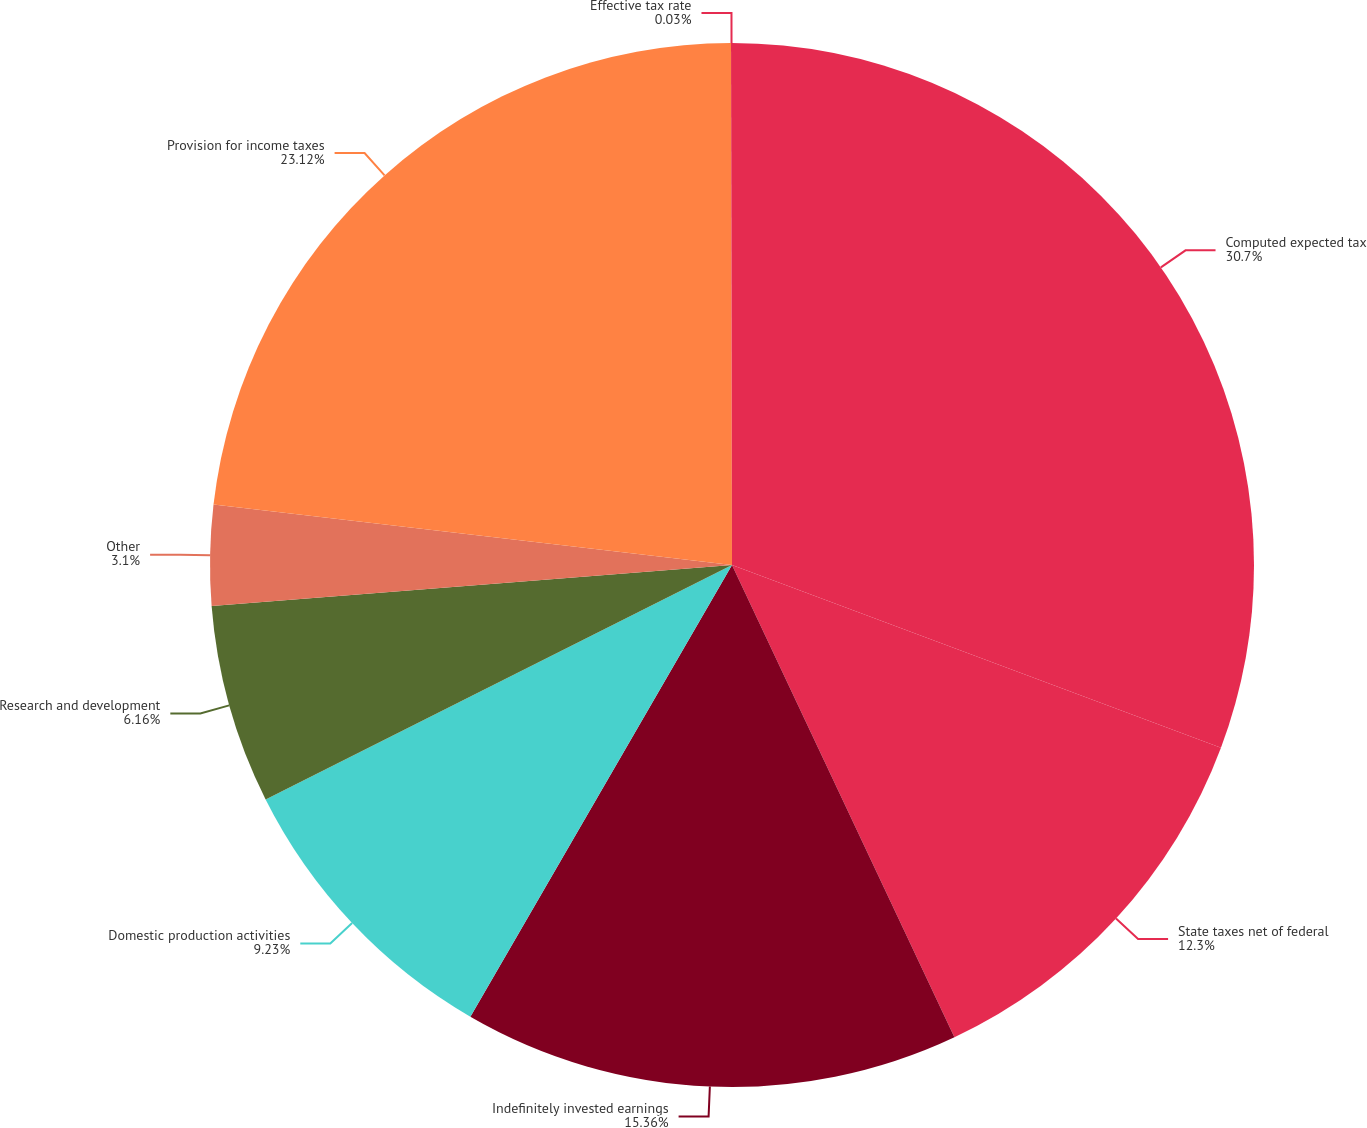<chart> <loc_0><loc_0><loc_500><loc_500><pie_chart><fcel>Computed expected tax<fcel>State taxes net of federal<fcel>Indefinitely invested earnings<fcel>Domestic production activities<fcel>Research and development<fcel>Other<fcel>Provision for income taxes<fcel>Effective tax rate<nl><fcel>30.69%<fcel>12.3%<fcel>15.36%<fcel>9.23%<fcel>6.16%<fcel>3.1%<fcel>23.12%<fcel>0.03%<nl></chart> 